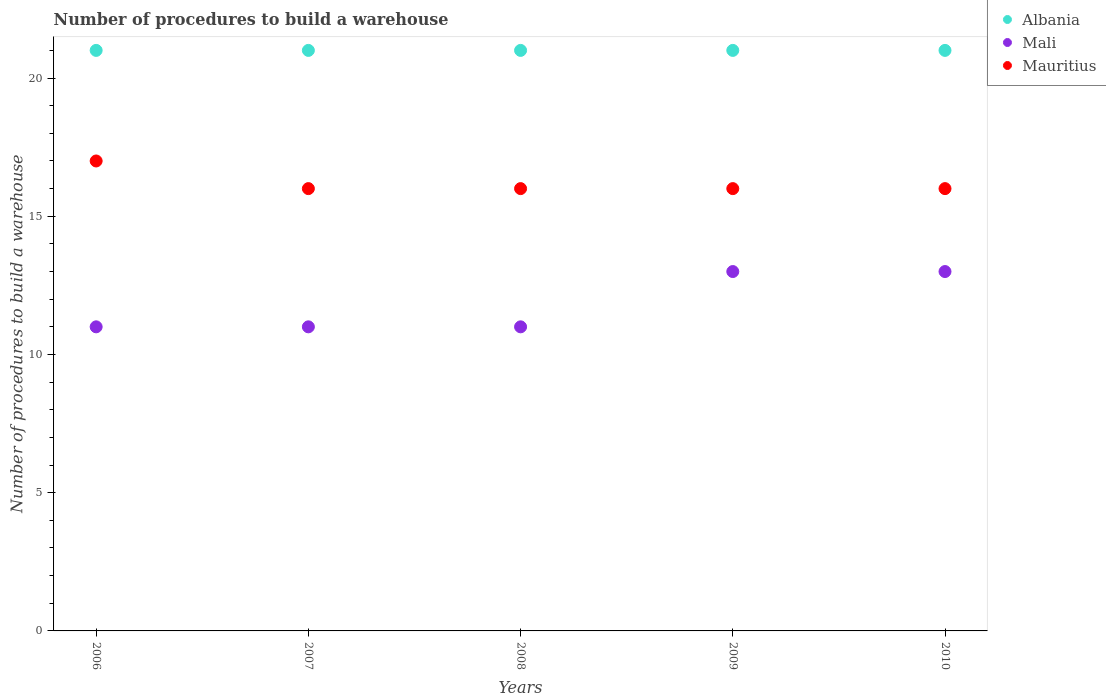Is the number of dotlines equal to the number of legend labels?
Make the answer very short. Yes. What is the number of procedures to build a warehouse in in Mauritius in 2007?
Give a very brief answer. 16. Across all years, what is the maximum number of procedures to build a warehouse in in Mauritius?
Make the answer very short. 17. Across all years, what is the minimum number of procedures to build a warehouse in in Albania?
Offer a terse response. 21. What is the total number of procedures to build a warehouse in in Albania in the graph?
Ensure brevity in your answer.  105. What is the difference between the number of procedures to build a warehouse in in Albania in 2006 and that in 2009?
Provide a succinct answer. 0. What is the difference between the number of procedures to build a warehouse in in Mali in 2009 and the number of procedures to build a warehouse in in Mauritius in 2010?
Offer a very short reply. -3. What is the average number of procedures to build a warehouse in in Mauritius per year?
Your answer should be compact. 16.2. In how many years, is the number of procedures to build a warehouse in in Mali greater than 14?
Your answer should be compact. 0. What is the ratio of the number of procedures to build a warehouse in in Albania in 2008 to that in 2009?
Offer a very short reply. 1. What is the difference between the highest and the lowest number of procedures to build a warehouse in in Mauritius?
Provide a short and direct response. 1. In how many years, is the number of procedures to build a warehouse in in Albania greater than the average number of procedures to build a warehouse in in Albania taken over all years?
Your response must be concise. 0. Is the sum of the number of procedures to build a warehouse in in Albania in 2007 and 2010 greater than the maximum number of procedures to build a warehouse in in Mali across all years?
Your answer should be compact. Yes. Is the number of procedures to build a warehouse in in Mauritius strictly greater than the number of procedures to build a warehouse in in Albania over the years?
Your answer should be very brief. No. Is the number of procedures to build a warehouse in in Mali strictly less than the number of procedures to build a warehouse in in Albania over the years?
Offer a very short reply. Yes. What is the difference between two consecutive major ticks on the Y-axis?
Give a very brief answer. 5. Are the values on the major ticks of Y-axis written in scientific E-notation?
Keep it short and to the point. No. Does the graph contain grids?
Your answer should be very brief. No. Where does the legend appear in the graph?
Offer a terse response. Top right. How are the legend labels stacked?
Your answer should be very brief. Vertical. What is the title of the graph?
Make the answer very short. Number of procedures to build a warehouse. Does "Madagascar" appear as one of the legend labels in the graph?
Offer a very short reply. No. What is the label or title of the X-axis?
Offer a very short reply. Years. What is the label or title of the Y-axis?
Give a very brief answer. Number of procedures to build a warehouse. What is the Number of procedures to build a warehouse in Mali in 2006?
Offer a terse response. 11. What is the Number of procedures to build a warehouse of Albania in 2007?
Give a very brief answer. 21. What is the Number of procedures to build a warehouse of Mauritius in 2007?
Ensure brevity in your answer.  16. What is the Number of procedures to build a warehouse of Mali in 2008?
Give a very brief answer. 11. What is the Number of procedures to build a warehouse of Mauritius in 2008?
Ensure brevity in your answer.  16. What is the Number of procedures to build a warehouse in Albania in 2009?
Your answer should be compact. 21. What is the Number of procedures to build a warehouse of Mauritius in 2009?
Your answer should be compact. 16. What is the Number of procedures to build a warehouse of Mali in 2010?
Ensure brevity in your answer.  13. What is the Number of procedures to build a warehouse in Mauritius in 2010?
Offer a terse response. 16. Across all years, what is the maximum Number of procedures to build a warehouse in Mali?
Your answer should be very brief. 13. Across all years, what is the maximum Number of procedures to build a warehouse of Mauritius?
Your response must be concise. 17. Across all years, what is the minimum Number of procedures to build a warehouse of Albania?
Offer a very short reply. 21. Across all years, what is the minimum Number of procedures to build a warehouse in Mali?
Provide a succinct answer. 11. What is the total Number of procedures to build a warehouse of Albania in the graph?
Your answer should be very brief. 105. What is the total Number of procedures to build a warehouse in Mali in the graph?
Your response must be concise. 59. What is the difference between the Number of procedures to build a warehouse of Mauritius in 2006 and that in 2007?
Give a very brief answer. 1. What is the difference between the Number of procedures to build a warehouse of Mauritius in 2006 and that in 2008?
Provide a short and direct response. 1. What is the difference between the Number of procedures to build a warehouse in Albania in 2006 and that in 2009?
Keep it short and to the point. 0. What is the difference between the Number of procedures to build a warehouse of Mali in 2006 and that in 2010?
Make the answer very short. -2. What is the difference between the Number of procedures to build a warehouse of Mauritius in 2006 and that in 2010?
Keep it short and to the point. 1. What is the difference between the Number of procedures to build a warehouse in Mali in 2007 and that in 2008?
Your response must be concise. 0. What is the difference between the Number of procedures to build a warehouse in Mauritius in 2007 and that in 2008?
Your response must be concise. 0. What is the difference between the Number of procedures to build a warehouse of Albania in 2007 and that in 2009?
Your answer should be very brief. 0. What is the difference between the Number of procedures to build a warehouse in Mauritius in 2007 and that in 2009?
Give a very brief answer. 0. What is the difference between the Number of procedures to build a warehouse of Mali in 2007 and that in 2010?
Your answer should be compact. -2. What is the difference between the Number of procedures to build a warehouse in Mauritius in 2007 and that in 2010?
Offer a terse response. 0. What is the difference between the Number of procedures to build a warehouse of Mauritius in 2008 and that in 2009?
Provide a succinct answer. 0. What is the difference between the Number of procedures to build a warehouse in Albania in 2008 and that in 2010?
Give a very brief answer. 0. What is the difference between the Number of procedures to build a warehouse of Albania in 2006 and the Number of procedures to build a warehouse of Mali in 2007?
Provide a succinct answer. 10. What is the difference between the Number of procedures to build a warehouse in Mali in 2006 and the Number of procedures to build a warehouse in Mauritius in 2007?
Give a very brief answer. -5. What is the difference between the Number of procedures to build a warehouse in Albania in 2006 and the Number of procedures to build a warehouse in Mauritius in 2008?
Your response must be concise. 5. What is the difference between the Number of procedures to build a warehouse of Mali in 2006 and the Number of procedures to build a warehouse of Mauritius in 2009?
Your response must be concise. -5. What is the difference between the Number of procedures to build a warehouse of Albania in 2007 and the Number of procedures to build a warehouse of Mali in 2008?
Your answer should be very brief. 10. What is the difference between the Number of procedures to build a warehouse in Albania in 2007 and the Number of procedures to build a warehouse in Mauritius in 2008?
Make the answer very short. 5. What is the difference between the Number of procedures to build a warehouse of Albania in 2007 and the Number of procedures to build a warehouse of Mali in 2009?
Make the answer very short. 8. What is the difference between the Number of procedures to build a warehouse in Albania in 2008 and the Number of procedures to build a warehouse in Mali in 2009?
Provide a short and direct response. 8. What is the difference between the Number of procedures to build a warehouse of Albania in 2008 and the Number of procedures to build a warehouse of Mali in 2010?
Ensure brevity in your answer.  8. What is the difference between the Number of procedures to build a warehouse of Albania in 2008 and the Number of procedures to build a warehouse of Mauritius in 2010?
Offer a terse response. 5. What is the difference between the Number of procedures to build a warehouse of Mali in 2008 and the Number of procedures to build a warehouse of Mauritius in 2010?
Offer a very short reply. -5. What is the difference between the Number of procedures to build a warehouse of Albania in 2009 and the Number of procedures to build a warehouse of Mali in 2010?
Your answer should be very brief. 8. What is the difference between the Number of procedures to build a warehouse of Albania in 2009 and the Number of procedures to build a warehouse of Mauritius in 2010?
Make the answer very short. 5. What is the difference between the Number of procedures to build a warehouse in Mali in 2009 and the Number of procedures to build a warehouse in Mauritius in 2010?
Provide a succinct answer. -3. What is the average Number of procedures to build a warehouse of Albania per year?
Your answer should be very brief. 21. In the year 2006, what is the difference between the Number of procedures to build a warehouse in Mali and Number of procedures to build a warehouse in Mauritius?
Give a very brief answer. -6. In the year 2007, what is the difference between the Number of procedures to build a warehouse of Albania and Number of procedures to build a warehouse of Mali?
Your answer should be very brief. 10. In the year 2009, what is the difference between the Number of procedures to build a warehouse of Albania and Number of procedures to build a warehouse of Mauritius?
Ensure brevity in your answer.  5. In the year 2010, what is the difference between the Number of procedures to build a warehouse of Albania and Number of procedures to build a warehouse of Mauritius?
Offer a terse response. 5. In the year 2010, what is the difference between the Number of procedures to build a warehouse in Mali and Number of procedures to build a warehouse in Mauritius?
Offer a terse response. -3. What is the ratio of the Number of procedures to build a warehouse in Albania in 2006 to that in 2007?
Your answer should be very brief. 1. What is the ratio of the Number of procedures to build a warehouse of Mali in 2006 to that in 2007?
Ensure brevity in your answer.  1. What is the ratio of the Number of procedures to build a warehouse of Mauritius in 2006 to that in 2007?
Your answer should be compact. 1.06. What is the ratio of the Number of procedures to build a warehouse in Albania in 2006 to that in 2008?
Provide a succinct answer. 1. What is the ratio of the Number of procedures to build a warehouse in Mali in 2006 to that in 2008?
Give a very brief answer. 1. What is the ratio of the Number of procedures to build a warehouse in Mauritius in 2006 to that in 2008?
Give a very brief answer. 1.06. What is the ratio of the Number of procedures to build a warehouse of Mali in 2006 to that in 2009?
Your answer should be compact. 0.85. What is the ratio of the Number of procedures to build a warehouse in Mauritius in 2006 to that in 2009?
Offer a terse response. 1.06. What is the ratio of the Number of procedures to build a warehouse of Mali in 2006 to that in 2010?
Your answer should be very brief. 0.85. What is the ratio of the Number of procedures to build a warehouse of Mauritius in 2006 to that in 2010?
Offer a very short reply. 1.06. What is the ratio of the Number of procedures to build a warehouse of Mali in 2007 to that in 2008?
Your response must be concise. 1. What is the ratio of the Number of procedures to build a warehouse of Mali in 2007 to that in 2009?
Keep it short and to the point. 0.85. What is the ratio of the Number of procedures to build a warehouse of Mali in 2007 to that in 2010?
Your answer should be very brief. 0.85. What is the ratio of the Number of procedures to build a warehouse of Mali in 2008 to that in 2009?
Make the answer very short. 0.85. What is the ratio of the Number of procedures to build a warehouse of Albania in 2008 to that in 2010?
Make the answer very short. 1. What is the ratio of the Number of procedures to build a warehouse of Mali in 2008 to that in 2010?
Your response must be concise. 0.85. What is the ratio of the Number of procedures to build a warehouse of Mali in 2009 to that in 2010?
Your response must be concise. 1. What is the ratio of the Number of procedures to build a warehouse of Mauritius in 2009 to that in 2010?
Offer a very short reply. 1. What is the difference between the highest and the second highest Number of procedures to build a warehouse in Albania?
Your answer should be very brief. 0. What is the difference between the highest and the lowest Number of procedures to build a warehouse of Mali?
Your answer should be very brief. 2. What is the difference between the highest and the lowest Number of procedures to build a warehouse of Mauritius?
Make the answer very short. 1. 